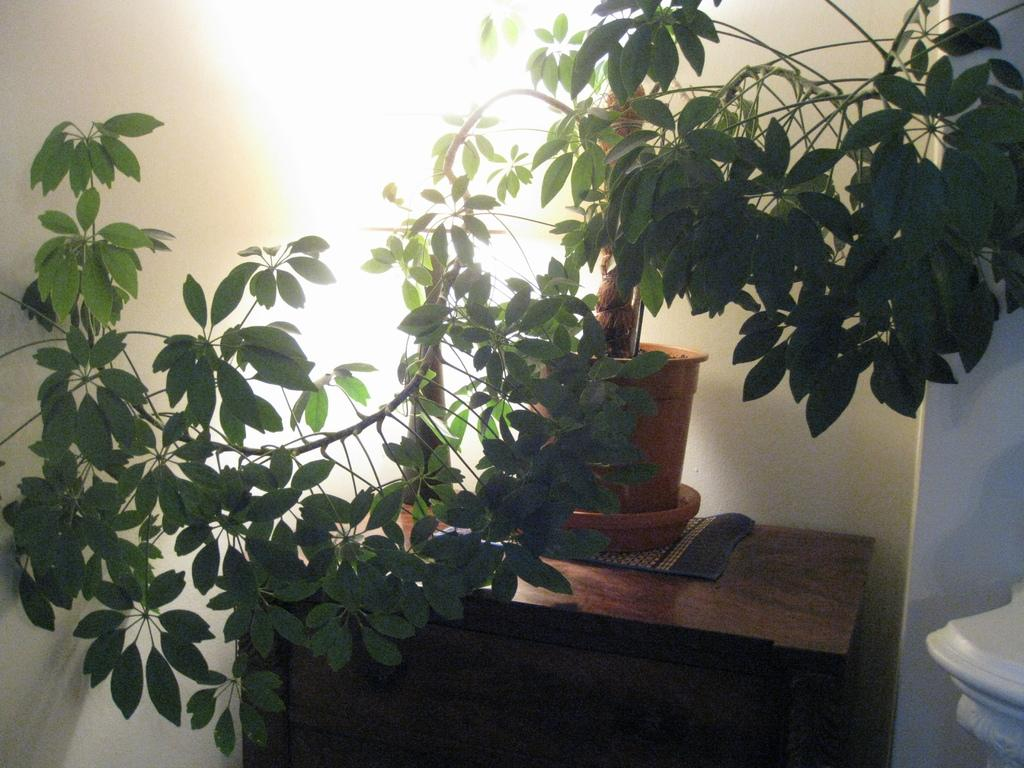What type of plant is in the flower pot in the image? The facts do not specify the type of plant in the flower pot. Where is the plant located in the image? The plant is on a table in the image. What can be seen at the bottom right side of the image? There is an object at the bottom right side of the image. What is visible in the background of the image? There is a wall in the background of the image. What type of cabbage is growing on the moon in the image? There is no cabbage or moon present in the image; it features a plant in a flower pot on a table with a wall in the background. 